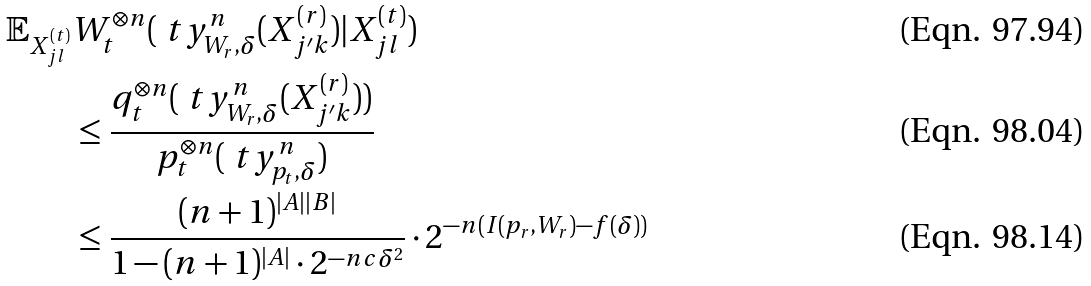Convert formula to latex. <formula><loc_0><loc_0><loc_500><loc_500>\mathbb { E } _ { X _ { j l } ^ { ( t ) } } & W _ { t } ^ { \otimes n } ( \ t y _ { W _ { r } , \delta } ^ { n } ( X _ { j ^ { \prime } k } ^ { ( r ) } ) | X _ { j l } ^ { ( t ) } ) \\ & \leq \frac { q _ { t } ^ { \otimes n } ( \ t y _ { W _ { r } , \delta } ^ { n } ( X _ { j ^ { \prime } k } ^ { ( r ) } ) ) } { p _ { t } ^ { \otimes n } ( \ t y _ { p _ { t } , \delta } ^ { n } ) } \\ & \leq \frac { ( n + 1 ) ^ { | A | | B | } } { 1 - ( n + 1 ) ^ { | A | } \cdot 2 ^ { - n c \delta ^ { 2 } } } \cdot 2 ^ { - n ( I ( p _ { r } , W _ { r } ) - f ( \delta ) ) }</formula> 